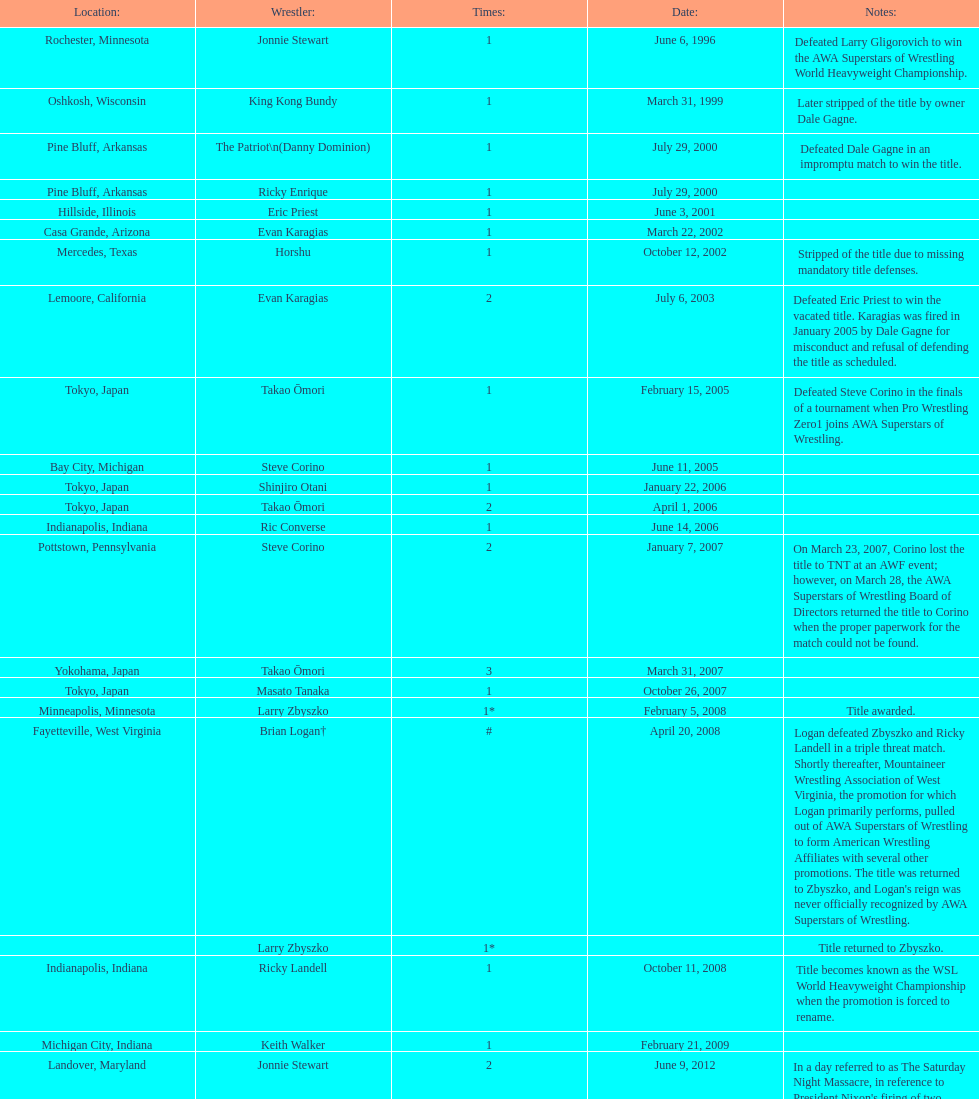Who is the only wsl title holder from texas? Horshu. 